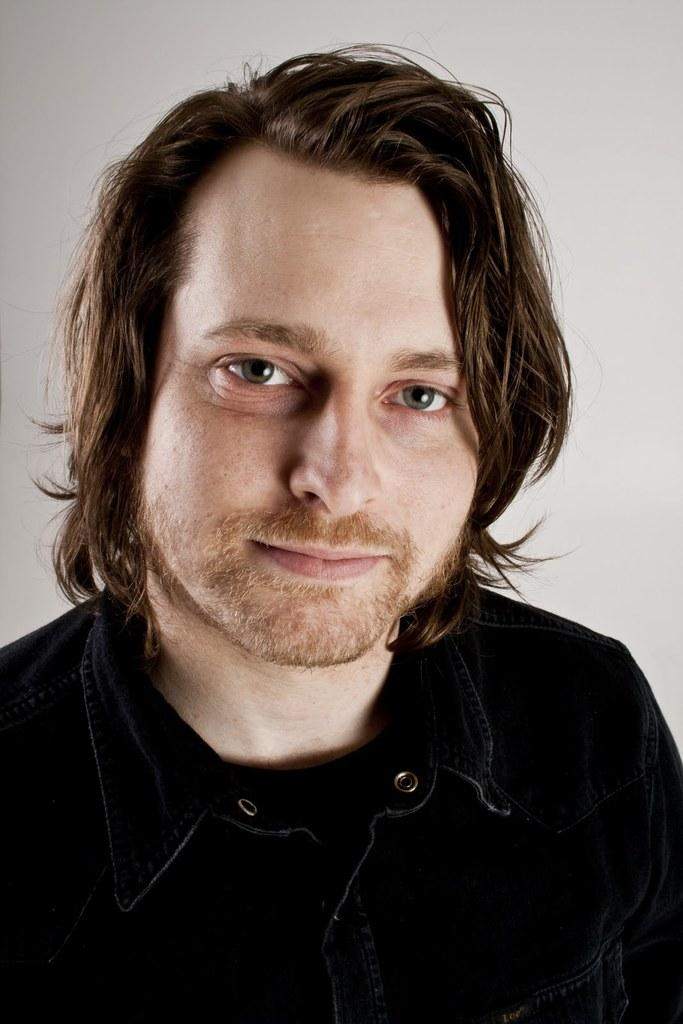What is the main subject in the foreground of the image? There is a man in the foreground of the image. What is the man wearing in the image? The man is wearing a black shirt in the image. What can be seen in the background of the image? There is a white wall in the background of the image. What example does the man in the image provide for his son? There is no indication in the image that the man is providing an example for his son, as the facts provided do not mention a son or any interaction between the man and another person. 